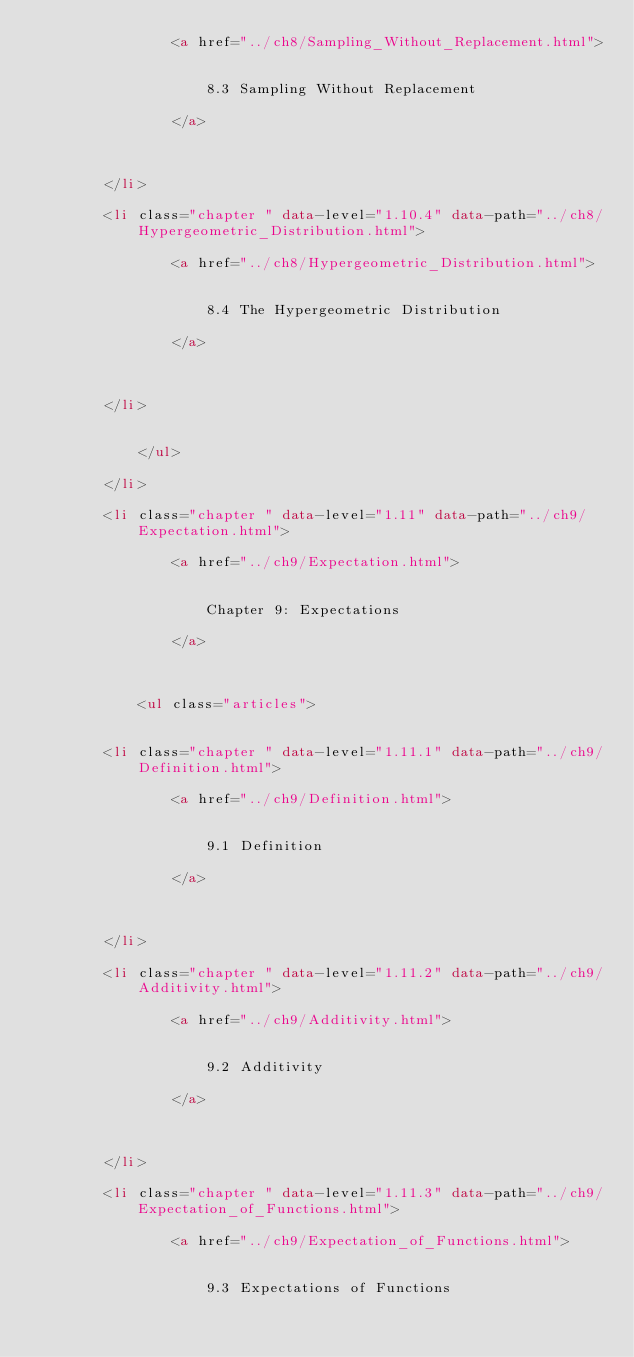Convert code to text. <code><loc_0><loc_0><loc_500><loc_500><_HTML_>                <a href="../ch8/Sampling_Without_Replacement.html">
            
                    
                    8.3 Sampling Without Replacement
            
                </a>
            

            
        </li>
    
        <li class="chapter " data-level="1.10.4" data-path="../ch8/Hypergeometric_Distribution.html">
            
                <a href="../ch8/Hypergeometric_Distribution.html">
            
                    
                    8.4 The Hypergeometric Distribution
            
                </a>
            

            
        </li>
    

            </ul>
            
        </li>
    
        <li class="chapter " data-level="1.11" data-path="../ch9/Expectation.html">
            
                <a href="../ch9/Expectation.html">
            
                    
                    Chapter 9: Expectations
            
                </a>
            

            
            <ul class="articles">
                
    
        <li class="chapter " data-level="1.11.1" data-path="../ch9/Definition.html">
            
                <a href="../ch9/Definition.html">
            
                    
                    9.1 Definition
            
                </a>
            

            
        </li>
    
        <li class="chapter " data-level="1.11.2" data-path="../ch9/Additivity.html">
            
                <a href="../ch9/Additivity.html">
            
                    
                    9.2 Additivity
            
                </a>
            

            
        </li>
    
        <li class="chapter " data-level="1.11.3" data-path="../ch9/Expectation_of_Functions.html">
            
                <a href="../ch9/Expectation_of_Functions.html">
            
                    
                    9.3 Expectations of Functions</code> 